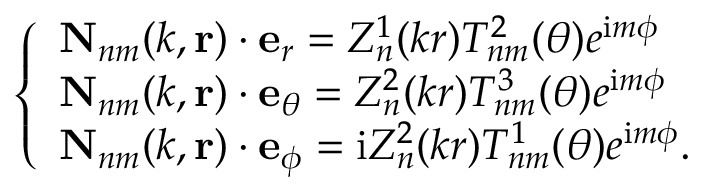<formula> <loc_0><loc_0><loc_500><loc_500>\left \{ \begin{array} { l l } { N _ { n m } ( k , r ) \cdot e _ { r } = Z _ { n } ^ { 1 } ( k r ) T _ { n m } ^ { 2 } ( \theta ) e ^ { i m \phi } } \\ { N _ { n m } ( k , r ) \cdot e _ { \theta } = Z _ { n } ^ { 2 } ( k r ) T _ { n m } ^ { 3 } ( \theta ) e ^ { i m \phi } } \\ { N _ { n m } ( k , r ) \cdot e _ { \phi } = i Z _ { n } ^ { 2 } ( k r ) T _ { n m } ^ { 1 } ( \theta ) e ^ { i m \phi } . } \end{array}</formula> 